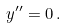Convert formula to latex. <formula><loc_0><loc_0><loc_500><loc_500>y ^ { \prime \prime } = 0 \, .</formula> 